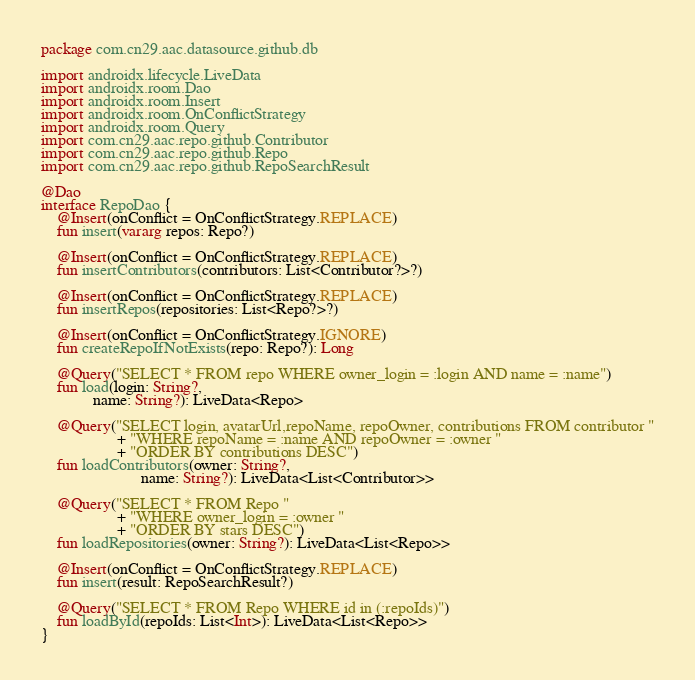Convert code to text. <code><loc_0><loc_0><loc_500><loc_500><_Kotlin_>package com.cn29.aac.datasource.github.db

import androidx.lifecycle.LiveData
import androidx.room.Dao
import androidx.room.Insert
import androidx.room.OnConflictStrategy
import androidx.room.Query
import com.cn29.aac.repo.github.Contributor
import com.cn29.aac.repo.github.Repo
import com.cn29.aac.repo.github.RepoSearchResult

@Dao
interface RepoDao {
    @Insert(onConflict = OnConflictStrategy.REPLACE)
    fun insert(vararg repos: Repo?)

    @Insert(onConflict = OnConflictStrategy.REPLACE)
    fun insertContributors(contributors: List<Contributor?>?)

    @Insert(onConflict = OnConflictStrategy.REPLACE)
    fun insertRepos(repositories: List<Repo?>?)

    @Insert(onConflict = OnConflictStrategy.IGNORE)
    fun createRepoIfNotExists(repo: Repo?): Long

    @Query("SELECT * FROM repo WHERE owner_login = :login AND name = :name")
    fun load(login: String?,
             name: String?): LiveData<Repo>

    @Query("SELECT login, avatarUrl,repoName, repoOwner, contributions FROM contributor "
                   + "WHERE repoName = :name AND repoOwner = :owner "
                   + "ORDER BY contributions DESC")
    fun loadContributors(owner: String?,
                         name: String?): LiveData<List<Contributor>>

    @Query("SELECT * FROM Repo "
                   + "WHERE owner_login = :owner "
                   + "ORDER BY stars DESC")
    fun loadRepositories(owner: String?): LiveData<List<Repo>>

    @Insert(onConflict = OnConflictStrategy.REPLACE)
    fun insert(result: RepoSearchResult?)

    @Query("SELECT * FROM Repo WHERE id in (:repoIds)")
    fun loadById(repoIds: List<Int>): LiveData<List<Repo>>
}</code> 